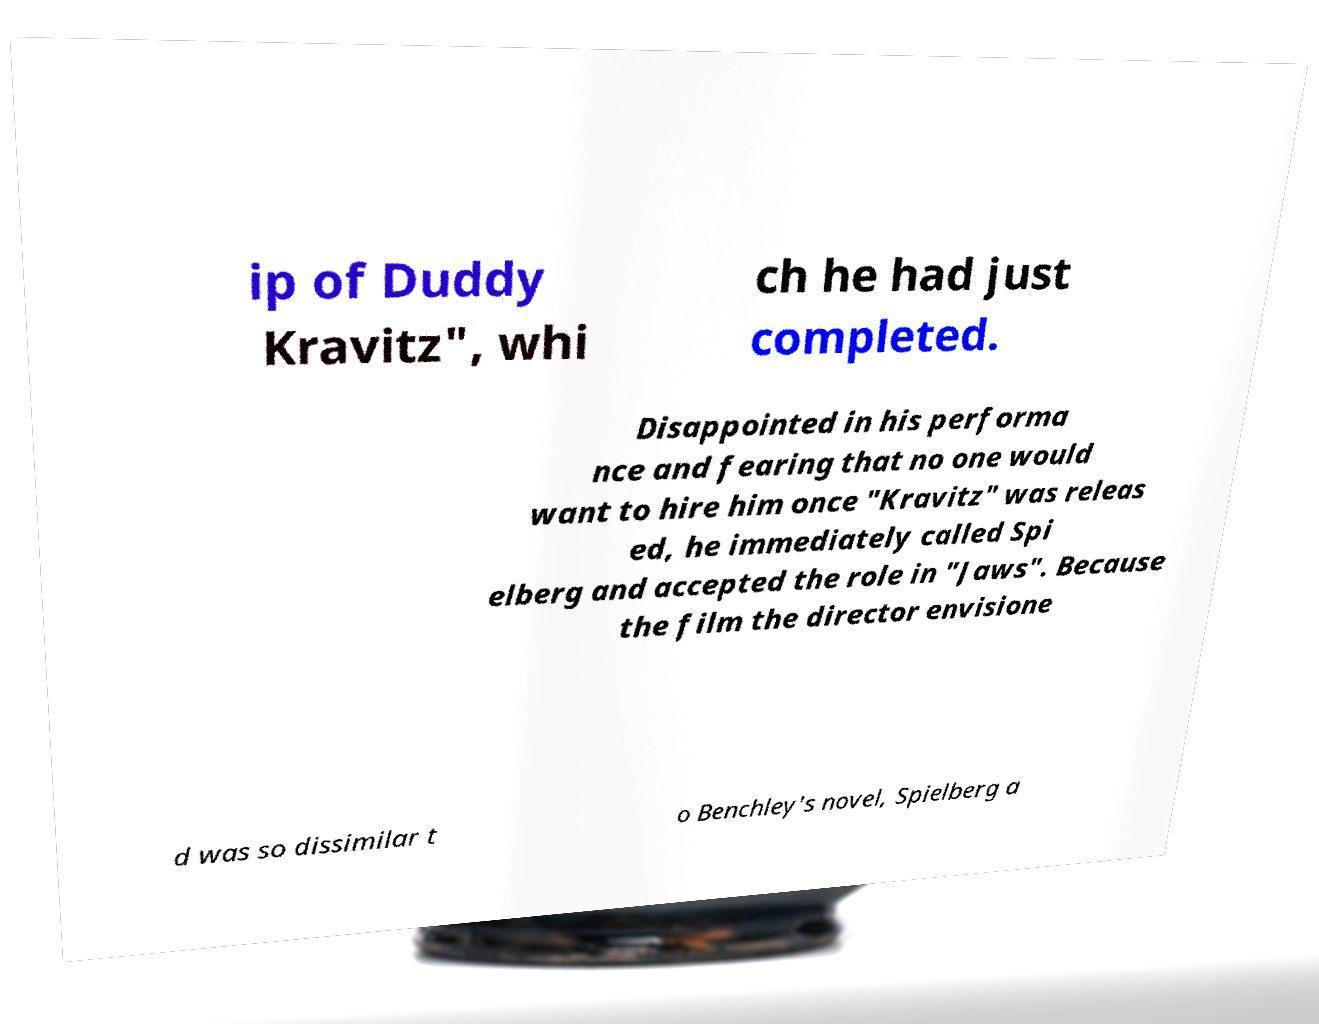Can you accurately transcribe the text from the provided image for me? ip of Duddy Kravitz", whi ch he had just completed. Disappointed in his performa nce and fearing that no one would want to hire him once "Kravitz" was releas ed, he immediately called Spi elberg and accepted the role in "Jaws". Because the film the director envisione d was so dissimilar t o Benchley's novel, Spielberg a 